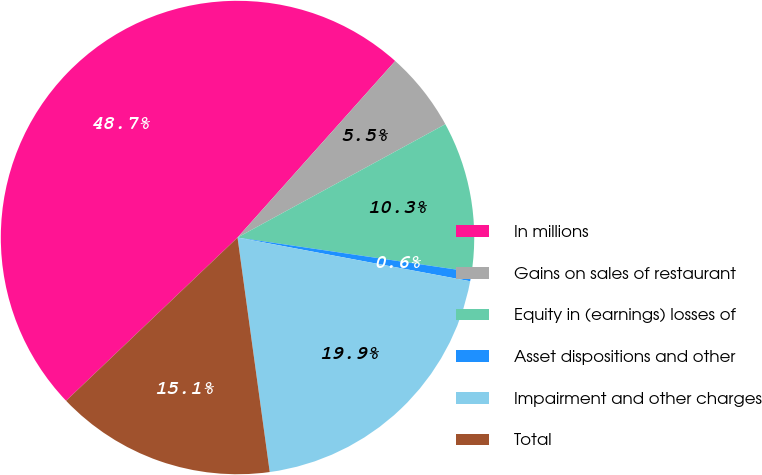<chart> <loc_0><loc_0><loc_500><loc_500><pie_chart><fcel>In millions<fcel>Gains on sales of restaurant<fcel>Equity in (earnings) losses of<fcel>Asset dispositions and other<fcel>Impairment and other charges<fcel>Total<nl><fcel>48.71%<fcel>5.45%<fcel>10.26%<fcel>0.64%<fcel>19.87%<fcel>15.06%<nl></chart> 